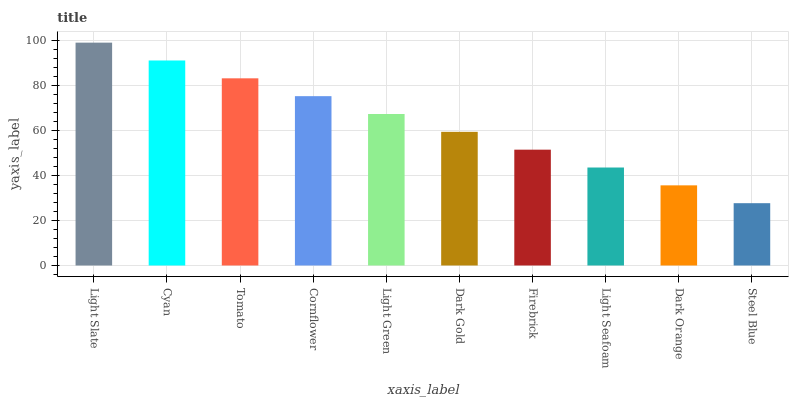Is Steel Blue the minimum?
Answer yes or no. Yes. Is Light Slate the maximum?
Answer yes or no. Yes. Is Cyan the minimum?
Answer yes or no. No. Is Cyan the maximum?
Answer yes or no. No. Is Light Slate greater than Cyan?
Answer yes or no. Yes. Is Cyan less than Light Slate?
Answer yes or no. Yes. Is Cyan greater than Light Slate?
Answer yes or no. No. Is Light Slate less than Cyan?
Answer yes or no. No. Is Light Green the high median?
Answer yes or no. Yes. Is Dark Gold the low median?
Answer yes or no. Yes. Is Light Slate the high median?
Answer yes or no. No. Is Dark Orange the low median?
Answer yes or no. No. 